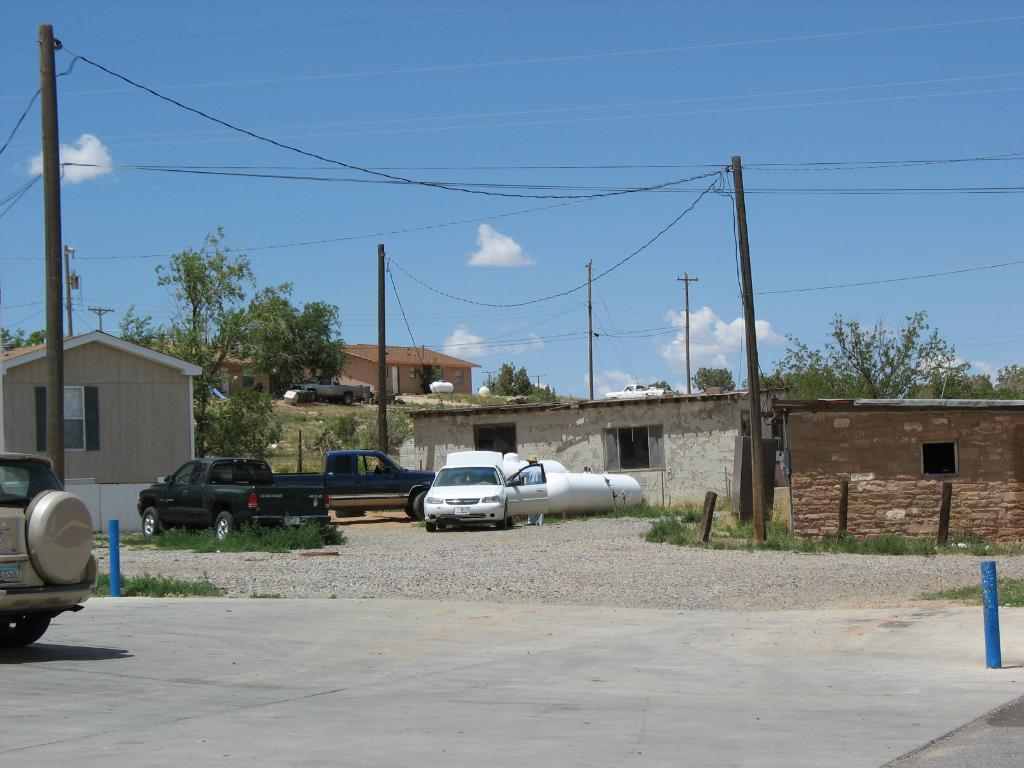What is visible in the center of the image? The sky is visible in the center of the image. What can be seen in the sky? Clouds are present in the image. What type of vegetation is in the image? Trees are in the image. What architectural features are present in the image? Poles and buildings are in the image. What mode of transportation can be seen in the image? Vehicles are in the image. What type of ground cover is in the image? Grass and stones are in the image. Can you tell me how many bridges are visible in the image? There are no bridges present in the image. What type of metal is used to construct the queen's throne in the image? There is no queen or throne present in the image. 